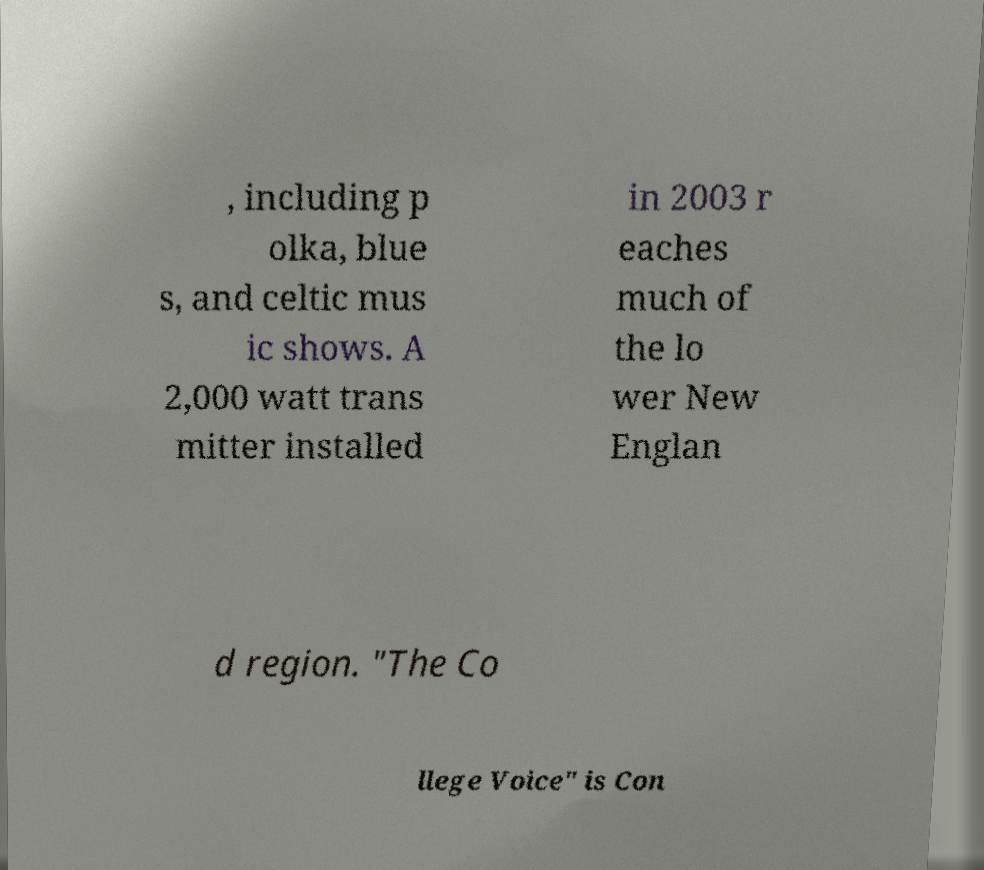Can you read and provide the text displayed in the image?This photo seems to have some interesting text. Can you extract and type it out for me? , including p olka, blue s, and celtic mus ic shows. A 2,000 watt trans mitter installed in 2003 r eaches much of the lo wer New Englan d region. "The Co llege Voice" is Con 